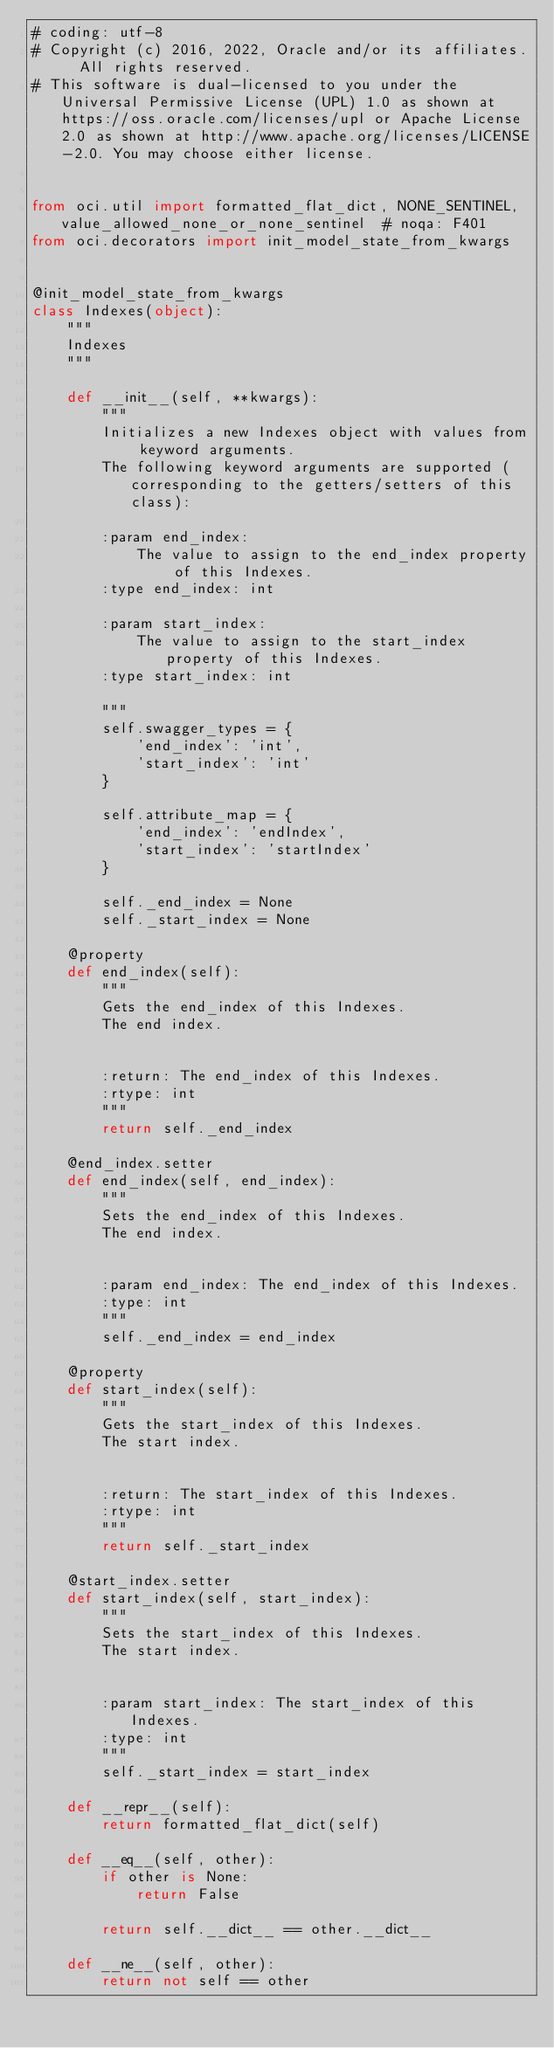<code> <loc_0><loc_0><loc_500><loc_500><_Python_># coding: utf-8
# Copyright (c) 2016, 2022, Oracle and/or its affiliates.  All rights reserved.
# This software is dual-licensed to you under the Universal Permissive License (UPL) 1.0 as shown at https://oss.oracle.com/licenses/upl or Apache License 2.0 as shown at http://www.apache.org/licenses/LICENSE-2.0. You may choose either license.


from oci.util import formatted_flat_dict, NONE_SENTINEL, value_allowed_none_or_none_sentinel  # noqa: F401
from oci.decorators import init_model_state_from_kwargs


@init_model_state_from_kwargs
class Indexes(object):
    """
    Indexes
    """

    def __init__(self, **kwargs):
        """
        Initializes a new Indexes object with values from keyword arguments.
        The following keyword arguments are supported (corresponding to the getters/setters of this class):

        :param end_index:
            The value to assign to the end_index property of this Indexes.
        :type end_index: int

        :param start_index:
            The value to assign to the start_index property of this Indexes.
        :type start_index: int

        """
        self.swagger_types = {
            'end_index': 'int',
            'start_index': 'int'
        }

        self.attribute_map = {
            'end_index': 'endIndex',
            'start_index': 'startIndex'
        }

        self._end_index = None
        self._start_index = None

    @property
    def end_index(self):
        """
        Gets the end_index of this Indexes.
        The end index.


        :return: The end_index of this Indexes.
        :rtype: int
        """
        return self._end_index

    @end_index.setter
    def end_index(self, end_index):
        """
        Sets the end_index of this Indexes.
        The end index.


        :param end_index: The end_index of this Indexes.
        :type: int
        """
        self._end_index = end_index

    @property
    def start_index(self):
        """
        Gets the start_index of this Indexes.
        The start index.


        :return: The start_index of this Indexes.
        :rtype: int
        """
        return self._start_index

    @start_index.setter
    def start_index(self, start_index):
        """
        Sets the start_index of this Indexes.
        The start index.


        :param start_index: The start_index of this Indexes.
        :type: int
        """
        self._start_index = start_index

    def __repr__(self):
        return formatted_flat_dict(self)

    def __eq__(self, other):
        if other is None:
            return False

        return self.__dict__ == other.__dict__

    def __ne__(self, other):
        return not self == other
</code> 